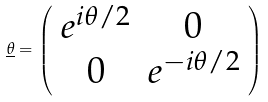Convert formula to latex. <formula><loc_0><loc_0><loc_500><loc_500>\underline { \theta } = \left ( \begin{array} { c c } e ^ { i \theta / 2 } & 0 \\ 0 & e ^ { - i \theta / 2 } \end{array} \right )</formula> 